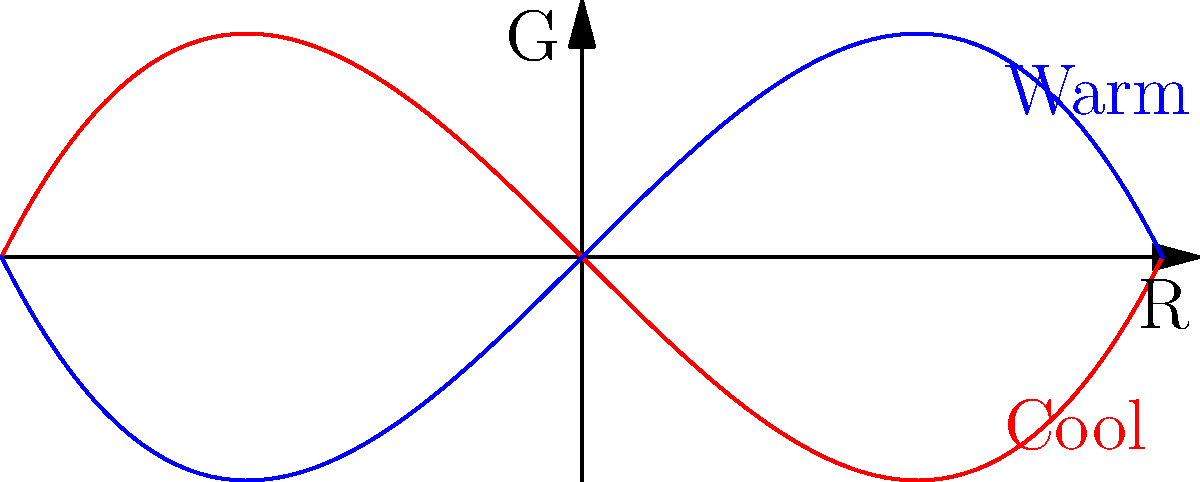In color grading for editorial fashion shoots, you want to create a cool, serene mood. Given the RGB color space graph, where the red curve represents cool tones and the blue curve represents warm tones, at which point along the R-axis would you adjust your image to achieve the maximum cool effect? To find the point of maximum cool effect, we need to follow these steps:

1. Observe that the red curve represents cool tones in the RGB color space.
2. The function for the cool tone curve is $f(x) = x^3 - x$.
3. To find the maximum point, we need to find where the derivative of this function equals zero:
   $f'(x) = 3x^2 - 1$
4. Set $f'(x) = 0$ and solve:
   $3x^2 - 1 = 0$
   $3x^2 = 1$
   $x^2 = \frac{1}{3}$
   $x = \pm \frac{1}{\sqrt{3}} \approx \pm 0.577$
5. The positive value $\frac{1}{\sqrt{3}}$ corresponds to the maximum point on the curve in the positive R direction.
6. This point represents the R-value where the cool effect is maximized in the RGB color space.

Therefore, to achieve the maximum cool effect, you should adjust your image at the R-value of $\frac{1}{\sqrt{3}}$ or approximately 0.577 on the R-axis.
Answer: $\frac{1}{\sqrt{3}}$ 